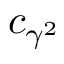Convert formula to latex. <formula><loc_0><loc_0><loc_500><loc_500>c _ { \gamma ^ { 2 } }</formula> 